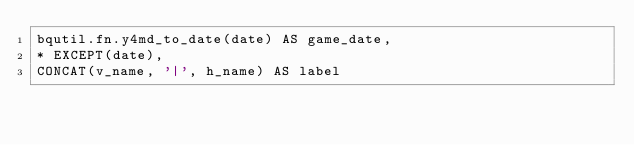Convert code to text. <code><loc_0><loc_0><loc_500><loc_500><_SQL_>bqutil.fn.y4md_to_date(date) AS game_date,
* EXCEPT(date),
CONCAT(v_name, '|', h_name) AS label
</code> 